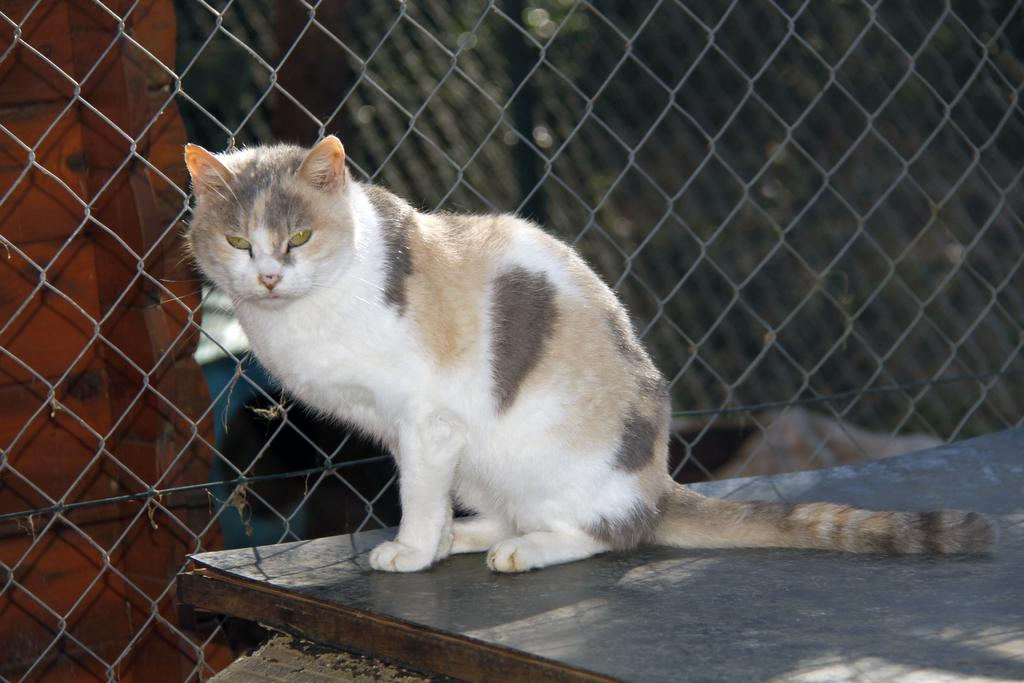What animal is present in the image? There is a cat in the image. What is the cat is standing on in the image? The cat is on a board. What type of material can be seen in the background of the image? There is mesh in the background of the image. What structure is visible in the background of the image? There is a wall visible in the background of the image. Can you see a bee playing volleyball with the cat in the image? No, there is no bee or volleyball present in the image. The image only features a cat on a board with a mesh and wall in the background. 